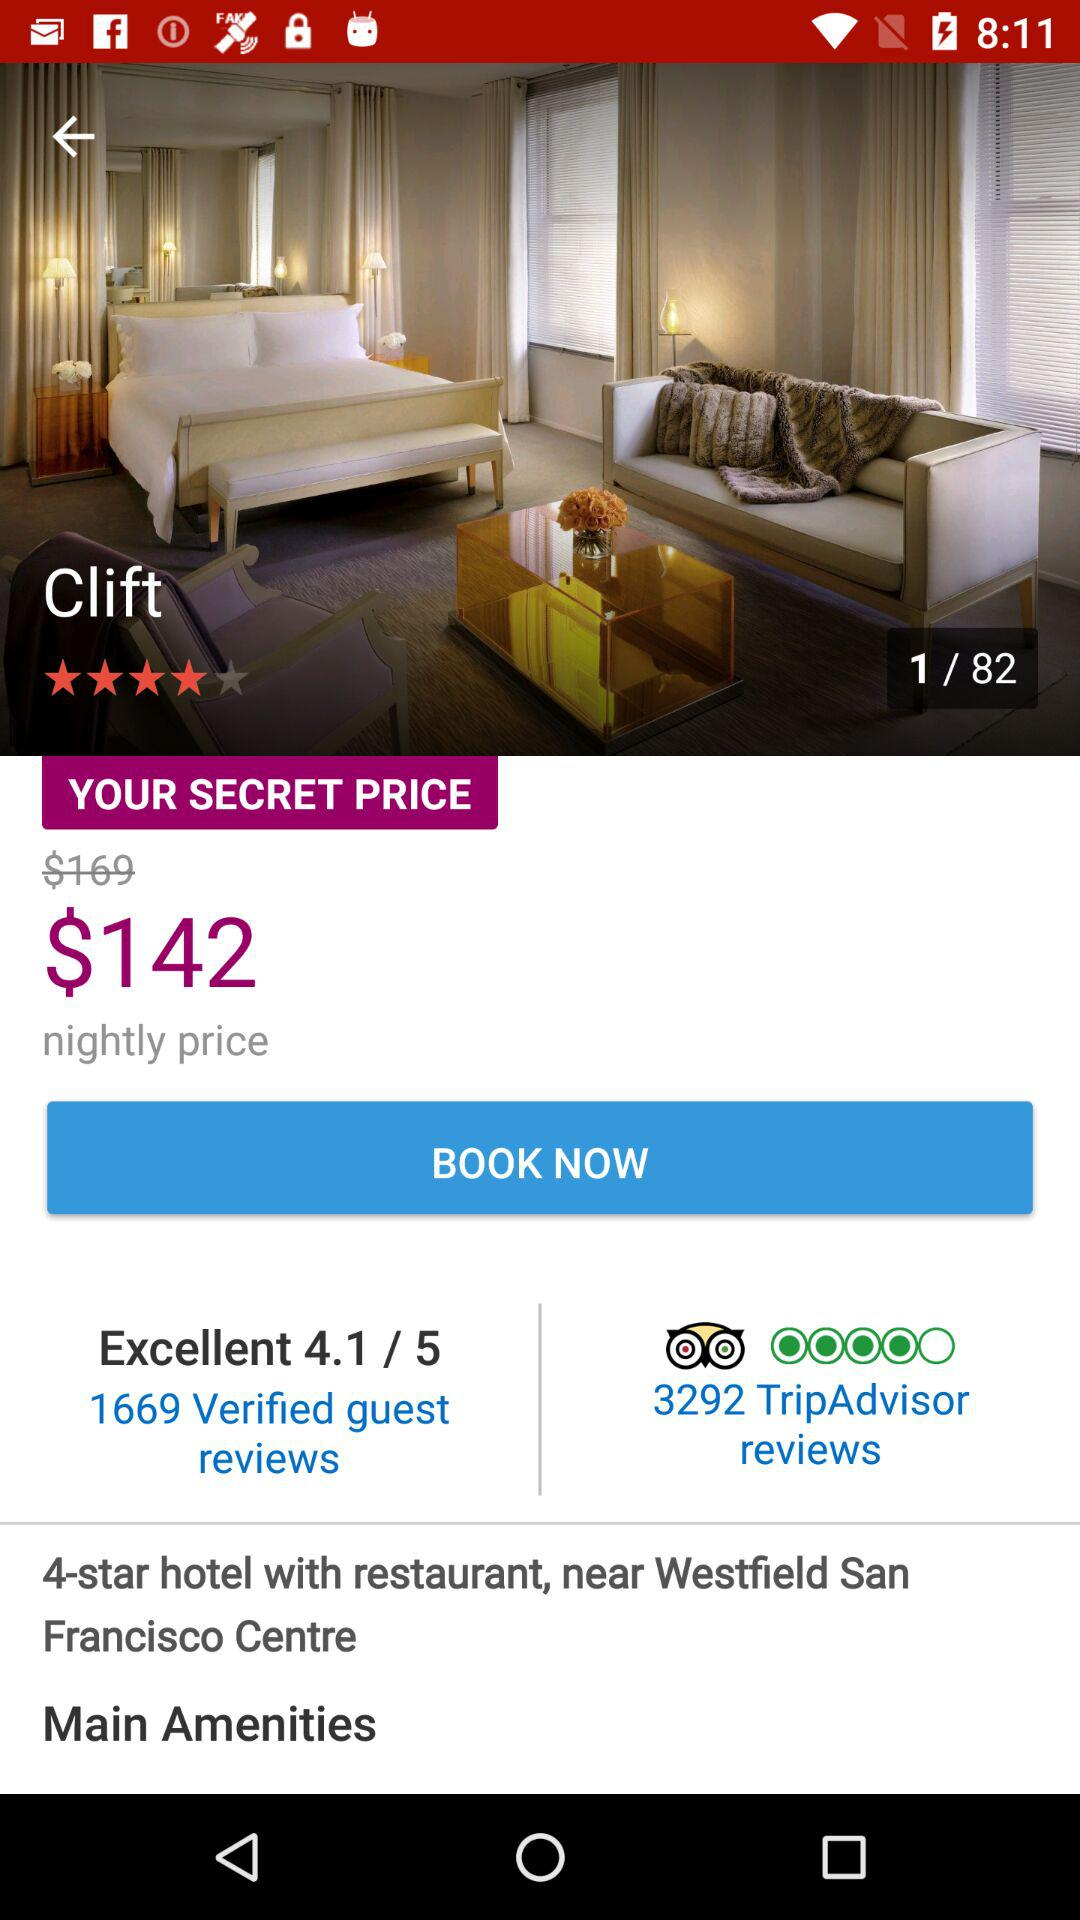How much is the price difference between the original and secret prices?
Answer the question using a single word or phrase. $27 